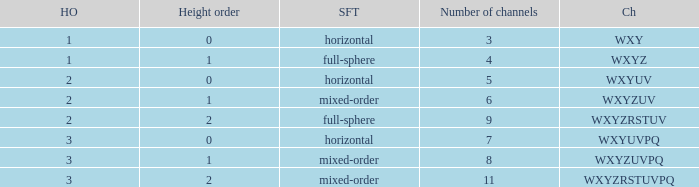If the height order is 1 and the soundfield type is mixed-order, what are all the channels? WXYZUV, WXYZUVPQ. 